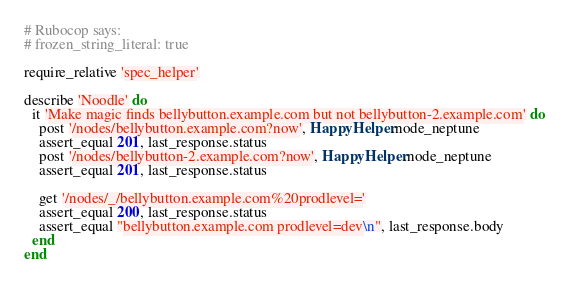Convert code to text. <code><loc_0><loc_0><loc_500><loc_500><_Ruby_># Rubocop says:
# frozen_string_literal: true

require_relative 'spec_helper'

describe 'Noodle' do
  it 'Make magic finds bellybutton.example.com but not bellybutton-2.example.com' do
    post '/nodes/bellybutton.example.com?now', HappyHelper.node_neptune
    assert_equal 201, last_response.status
    post '/nodes/bellybutton-2.example.com?now', HappyHelper.node_neptune
    assert_equal 201, last_response.status

    get '/nodes/_/bellybutton.example.com%20prodlevel='
    assert_equal 200, last_response.status
    assert_equal "bellybutton.example.com prodlevel=dev\n", last_response.body
  end
end
</code> 